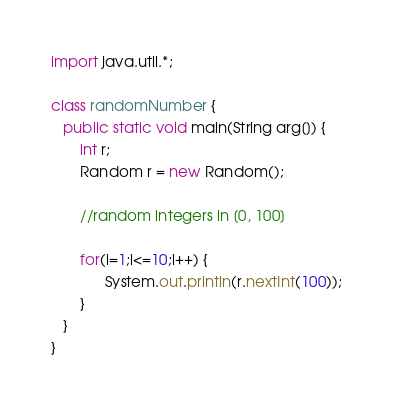Convert code to text. <code><loc_0><loc_0><loc_500><loc_500><_Java_>import java.util.*;

class randomNumber {
   public static void main(String arg[]) {
	   int r;
	   Random r = new Random();
	   
	   //random integers in [0, 100]
	   
	   for(i=1;i<=10;i++) {
		     System.out.println(r.nextInt(100));
	   }
   }
}</code> 